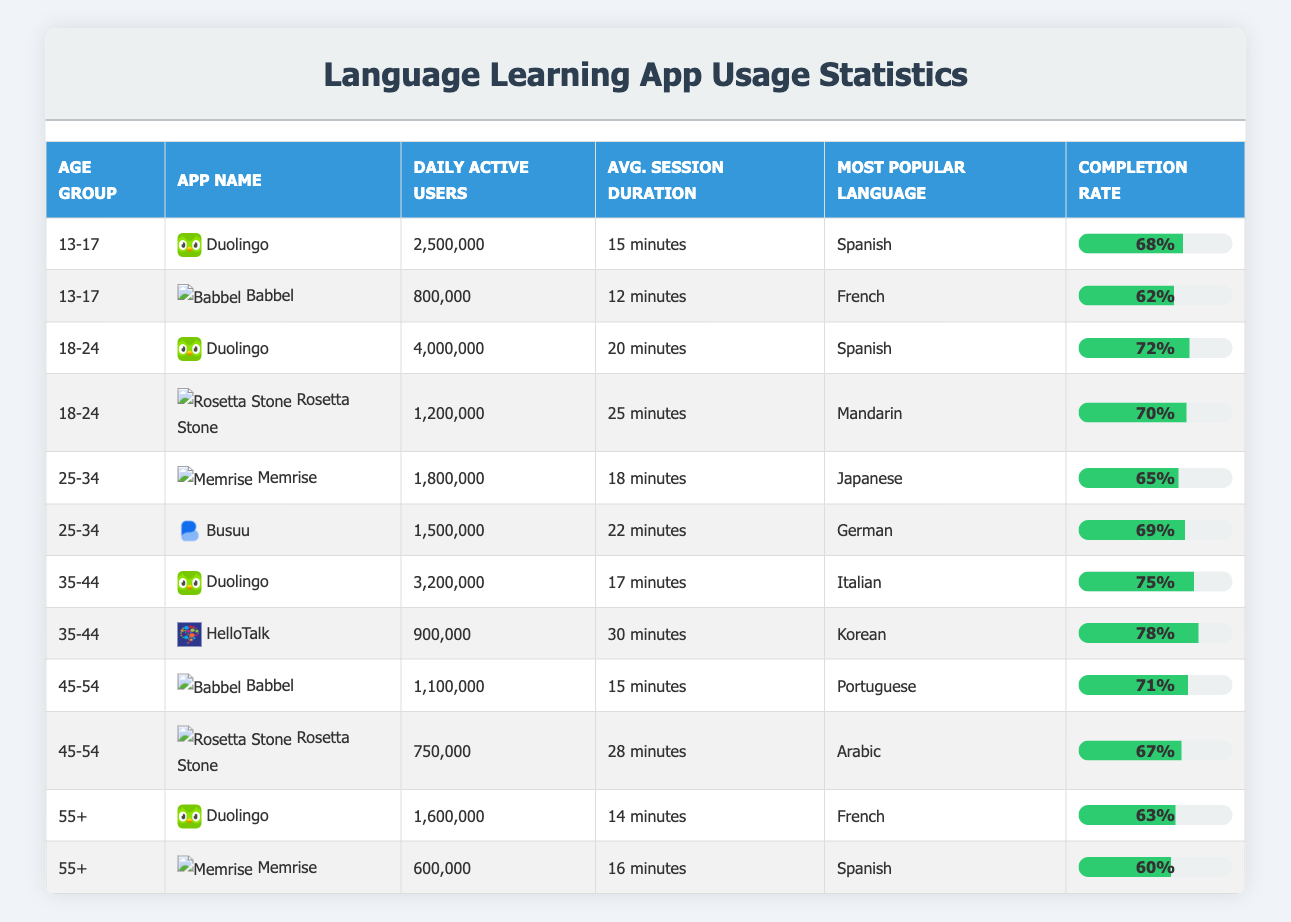What is the most popular language learned by users aged 13-17? In the table, under the age group "13-17", Duolingo has Spanish listed as the most popular language, and Babbel has French listed. Since we are looking for the most popular among them, Spanish is mentioned first for Duolingo with 2,500,000 users.
Answer: Spanish Which app has the highest completion rate in the age group 35-44? From the table, in the age group 35-44, we have Duolingo with a 75% completion rate and HelloTalk with a 78% completion rate. Comparing these values, HelloTalk has the highest completion rate in this age group.
Answer: HelloTalk How many daily active users does Babbel have in the age group 45-54? Looking at the table, for the age group 45-54, Babbel is listed with 1,100,000 daily active users. This value is found directly from the corresponding row in the table.
Answer: 1,100,000 What is the average session duration for users aged 55 and older across the two apps? For the age group 55+, Duolingo has an average session duration of 14 minutes, and Memrise has 16 minutes. To find the average, sum these two values (14 + 16 = 30 minutes) and divide by the number of apps (2). Thus, the average session duration is 30/2 = 15 minutes.
Answer: 15 minutes Is Duolingo the most used app for all age groups in the table? Reviewing the data, Duolingo appears in every age group. However, while it has the highest number of daily active users in some of them, like 13-17 and 18-24, it is not the case for the age group 35-44, where it has lesser users than HelloTalk. Hence, it cannot be said that Duolingo is the most used app across all age groups.
Answer: No Which age group has the lowest average session duration and what is that duration? First, we note the average session durations for all age groups: 13-17 has 13.5 minutes (average of 15 and 12), 18-24 has 22.5 minutes (average of 20 and 25), 25-34 has 20 minutes (average of 18 and 22), 35-44 has 23.5 minutes (average of 17 and 30), 45-54 has 21.5 minutes (average of 15 and 28), and 55+ has 15 minutes (average of 14 and 16). The lowest among these is 15 minutes in the age group 55+.
Answer: 15 minutes What is the total daily active users for apps in the age group 25-34? From the table, in the age group 25-34, Memrise has 1,800,000 daily active users and Busuu has 1,500,000 daily active users. Adding these two values gives us a total of 1,800,000 + 1,500,000 = 3,300,000 daily active users for this age group.
Answer: 3,300,000 In which age group does Rosetta Stone have the highest number of daily active users? The only age group listed for Rosetta Stone is 18-24 with 1,200,000 daily active users, and also in 45-54 with 750,000 users. Therefore, the age group 18-24 has the highest number of daily active users for Rosetta Stone.
Answer: 18-24 Which app has the highest number of daily active users across all age groups? The values for daily active users show that Duolingo in the age group 18-24 has the highest number with 4,000,000 users. Checking all the other values, none exceed this number. Thus, Duolingo holds the highest overall count.
Answer: Duolingo 